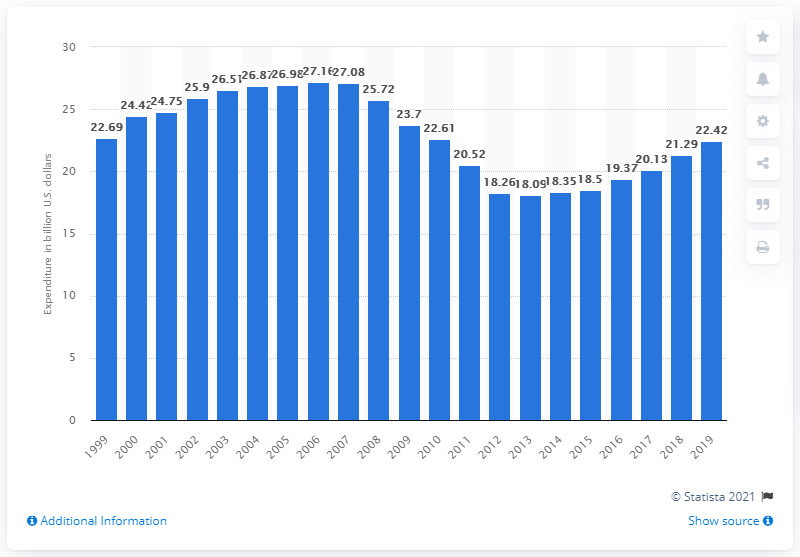What was the consumer expenditure on recreational books in the United States in 2019?
 22.42 